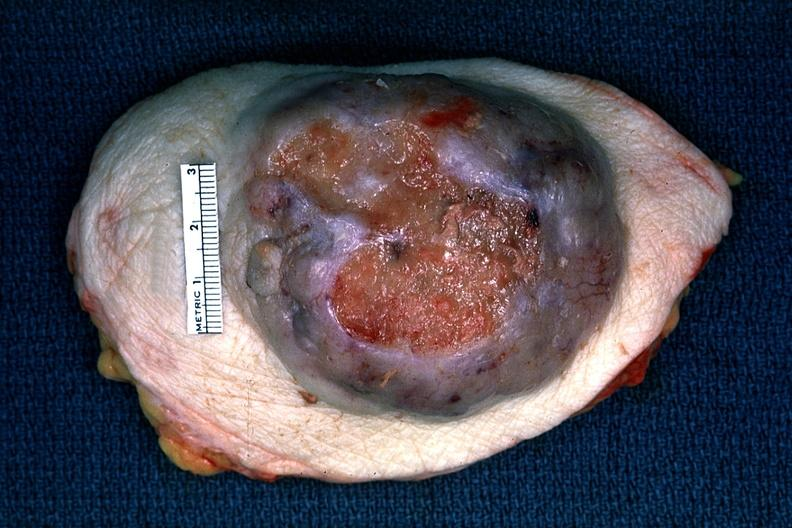what is present?
Answer the question using a single word or phrase. Adenocarcinoma 